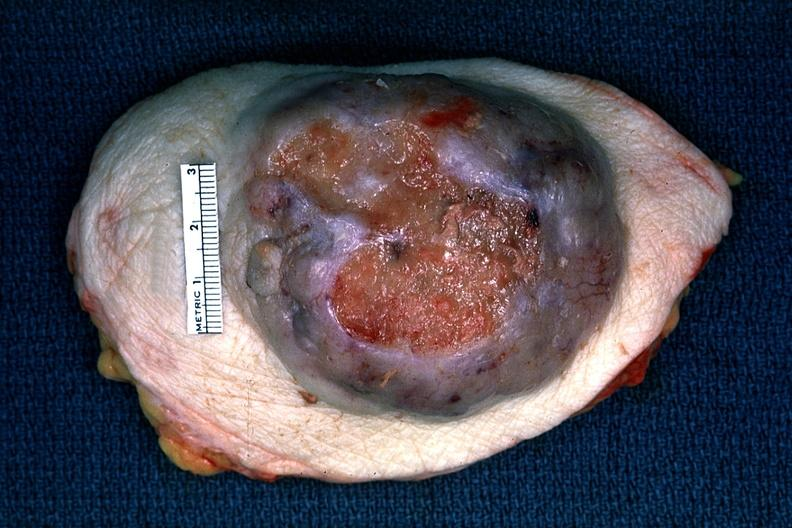what is present?
Answer the question using a single word or phrase. Adenocarcinoma 